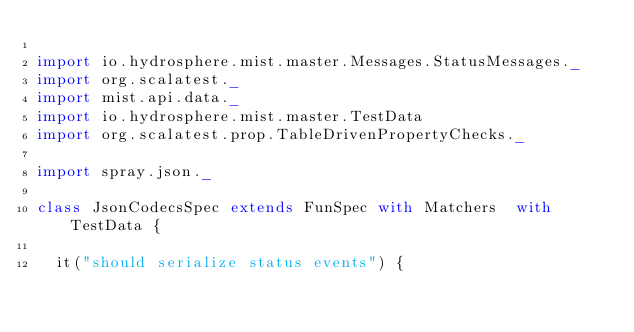<code> <loc_0><loc_0><loc_500><loc_500><_Scala_>
import io.hydrosphere.mist.master.Messages.StatusMessages._
import org.scalatest._
import mist.api.data._
import io.hydrosphere.mist.master.TestData
import org.scalatest.prop.TableDrivenPropertyChecks._

import spray.json._

class JsonCodecsSpec extends FunSpec with Matchers  with TestData {

  it("should serialize status events") {</code> 